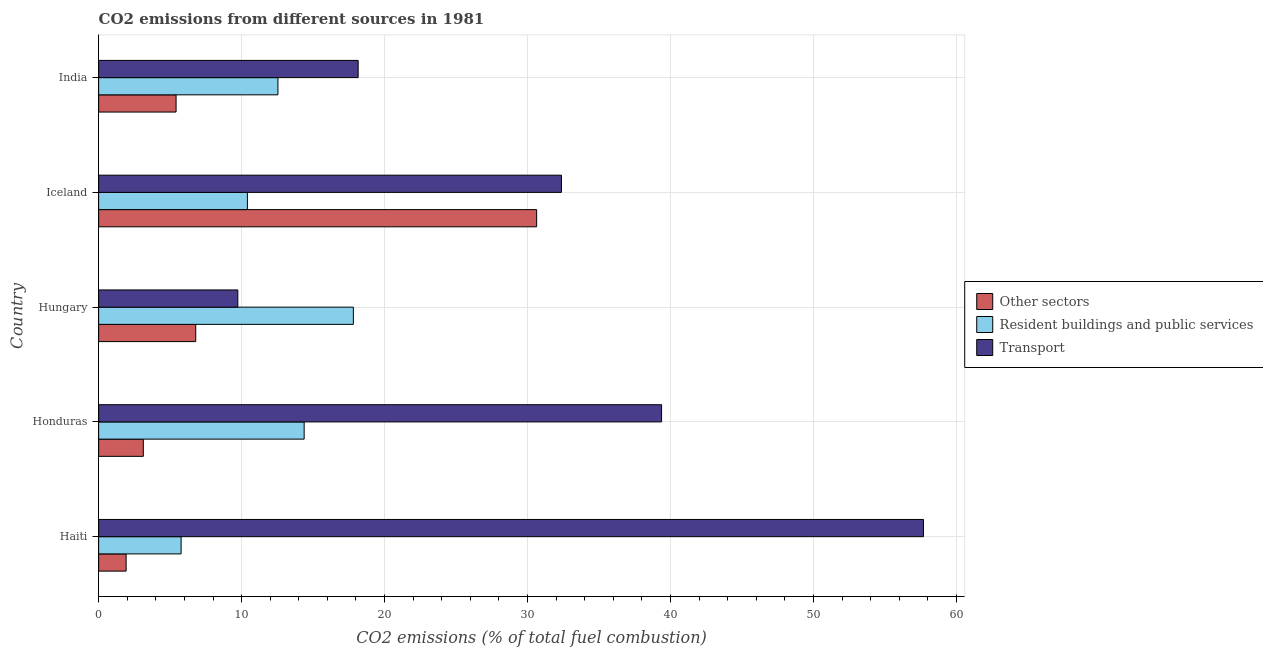How many different coloured bars are there?
Your answer should be compact. 3. Are the number of bars per tick equal to the number of legend labels?
Give a very brief answer. Yes. Are the number of bars on each tick of the Y-axis equal?
Your answer should be very brief. Yes. How many bars are there on the 2nd tick from the top?
Provide a succinct answer. 3. How many bars are there on the 4th tick from the bottom?
Give a very brief answer. 3. What is the label of the 3rd group of bars from the top?
Your answer should be very brief. Hungary. What is the percentage of co2 emissions from other sectors in Haiti?
Your answer should be very brief. 1.92. Across all countries, what is the maximum percentage of co2 emissions from resident buildings and public services?
Offer a very short reply. 17.82. Across all countries, what is the minimum percentage of co2 emissions from other sectors?
Give a very brief answer. 1.92. In which country was the percentage of co2 emissions from transport maximum?
Keep it short and to the point. Haiti. In which country was the percentage of co2 emissions from transport minimum?
Provide a succinct answer. Hungary. What is the total percentage of co2 emissions from other sectors in the graph?
Offer a very short reply. 47.89. What is the difference between the percentage of co2 emissions from other sectors in Honduras and that in Hungary?
Ensure brevity in your answer.  -3.67. What is the difference between the percentage of co2 emissions from transport in Hungary and the percentage of co2 emissions from other sectors in India?
Ensure brevity in your answer.  4.32. What is the average percentage of co2 emissions from other sectors per country?
Offer a terse response. 9.58. What is the difference between the percentage of co2 emissions from transport and percentage of co2 emissions from resident buildings and public services in Haiti?
Your response must be concise. 51.92. What is the ratio of the percentage of co2 emissions from other sectors in Haiti to that in Honduras?
Offer a very short reply. 0.61. Is the percentage of co2 emissions from other sectors in Haiti less than that in India?
Your answer should be compact. Yes. Is the difference between the percentage of co2 emissions from resident buildings and public services in Haiti and Honduras greater than the difference between the percentage of co2 emissions from other sectors in Haiti and Honduras?
Provide a succinct answer. No. What is the difference between the highest and the second highest percentage of co2 emissions from transport?
Your response must be concise. 18.32. What is the difference between the highest and the lowest percentage of co2 emissions from other sectors?
Give a very brief answer. 28.71. Is the sum of the percentage of co2 emissions from transport in Honduras and India greater than the maximum percentage of co2 emissions from resident buildings and public services across all countries?
Offer a very short reply. Yes. What does the 1st bar from the top in Honduras represents?
Give a very brief answer. Transport. What does the 2nd bar from the bottom in Iceland represents?
Provide a succinct answer. Resident buildings and public services. Is it the case that in every country, the sum of the percentage of co2 emissions from other sectors and percentage of co2 emissions from resident buildings and public services is greater than the percentage of co2 emissions from transport?
Provide a succinct answer. No. How many bars are there?
Keep it short and to the point. 15. Are all the bars in the graph horizontal?
Make the answer very short. Yes. Are the values on the major ticks of X-axis written in scientific E-notation?
Give a very brief answer. No. Does the graph contain any zero values?
Your answer should be very brief. No. Does the graph contain grids?
Give a very brief answer. Yes. What is the title of the graph?
Keep it short and to the point. CO2 emissions from different sources in 1981. Does "Poland" appear as one of the legend labels in the graph?
Your response must be concise. No. What is the label or title of the X-axis?
Ensure brevity in your answer.  CO2 emissions (% of total fuel combustion). What is the CO2 emissions (% of total fuel combustion) in Other sectors in Haiti?
Your response must be concise. 1.92. What is the CO2 emissions (% of total fuel combustion) of Resident buildings and public services in Haiti?
Make the answer very short. 5.77. What is the CO2 emissions (% of total fuel combustion) in Transport in Haiti?
Ensure brevity in your answer.  57.69. What is the CO2 emissions (% of total fuel combustion) of Other sectors in Honduras?
Your answer should be very brief. 3.12. What is the CO2 emissions (% of total fuel combustion) of Resident buildings and public services in Honduras?
Offer a terse response. 14.38. What is the CO2 emissions (% of total fuel combustion) of Transport in Honduras?
Make the answer very short. 39.38. What is the CO2 emissions (% of total fuel combustion) in Other sectors in Hungary?
Make the answer very short. 6.79. What is the CO2 emissions (% of total fuel combustion) of Resident buildings and public services in Hungary?
Your response must be concise. 17.82. What is the CO2 emissions (% of total fuel combustion) in Transport in Hungary?
Your response must be concise. 9.73. What is the CO2 emissions (% of total fuel combustion) of Other sectors in Iceland?
Give a very brief answer. 30.64. What is the CO2 emissions (% of total fuel combustion) in Resident buildings and public services in Iceland?
Give a very brief answer. 10.4. What is the CO2 emissions (% of total fuel combustion) in Transport in Iceland?
Make the answer very short. 32.37. What is the CO2 emissions (% of total fuel combustion) of Other sectors in India?
Keep it short and to the point. 5.42. What is the CO2 emissions (% of total fuel combustion) in Resident buildings and public services in India?
Your answer should be very brief. 12.54. What is the CO2 emissions (% of total fuel combustion) in Transport in India?
Provide a succinct answer. 18.15. Across all countries, what is the maximum CO2 emissions (% of total fuel combustion) in Other sectors?
Your answer should be compact. 30.64. Across all countries, what is the maximum CO2 emissions (% of total fuel combustion) of Resident buildings and public services?
Your answer should be very brief. 17.82. Across all countries, what is the maximum CO2 emissions (% of total fuel combustion) in Transport?
Make the answer very short. 57.69. Across all countries, what is the minimum CO2 emissions (% of total fuel combustion) in Other sectors?
Make the answer very short. 1.92. Across all countries, what is the minimum CO2 emissions (% of total fuel combustion) of Resident buildings and public services?
Offer a very short reply. 5.77. Across all countries, what is the minimum CO2 emissions (% of total fuel combustion) of Transport?
Offer a terse response. 9.73. What is the total CO2 emissions (% of total fuel combustion) of Other sectors in the graph?
Provide a succinct answer. 47.89. What is the total CO2 emissions (% of total fuel combustion) of Resident buildings and public services in the graph?
Your answer should be very brief. 60.91. What is the total CO2 emissions (% of total fuel combustion) in Transport in the graph?
Your answer should be compact. 157.32. What is the difference between the CO2 emissions (% of total fuel combustion) in Other sectors in Haiti and that in Honduras?
Offer a terse response. -1.2. What is the difference between the CO2 emissions (% of total fuel combustion) of Resident buildings and public services in Haiti and that in Honduras?
Your response must be concise. -8.61. What is the difference between the CO2 emissions (% of total fuel combustion) of Transport in Haiti and that in Honduras?
Give a very brief answer. 18.32. What is the difference between the CO2 emissions (% of total fuel combustion) in Other sectors in Haiti and that in Hungary?
Keep it short and to the point. -4.87. What is the difference between the CO2 emissions (% of total fuel combustion) in Resident buildings and public services in Haiti and that in Hungary?
Provide a succinct answer. -12.05. What is the difference between the CO2 emissions (% of total fuel combustion) in Transport in Haiti and that in Hungary?
Offer a very short reply. 47.96. What is the difference between the CO2 emissions (% of total fuel combustion) in Other sectors in Haiti and that in Iceland?
Your answer should be compact. -28.71. What is the difference between the CO2 emissions (% of total fuel combustion) of Resident buildings and public services in Haiti and that in Iceland?
Provide a succinct answer. -4.64. What is the difference between the CO2 emissions (% of total fuel combustion) of Transport in Haiti and that in Iceland?
Ensure brevity in your answer.  25.32. What is the difference between the CO2 emissions (% of total fuel combustion) of Other sectors in Haiti and that in India?
Offer a very short reply. -3.49. What is the difference between the CO2 emissions (% of total fuel combustion) of Resident buildings and public services in Haiti and that in India?
Your answer should be compact. -6.77. What is the difference between the CO2 emissions (% of total fuel combustion) of Transport in Haiti and that in India?
Your answer should be compact. 39.54. What is the difference between the CO2 emissions (% of total fuel combustion) of Other sectors in Honduras and that in Hungary?
Provide a short and direct response. -3.67. What is the difference between the CO2 emissions (% of total fuel combustion) of Resident buildings and public services in Honduras and that in Hungary?
Make the answer very short. -3.44. What is the difference between the CO2 emissions (% of total fuel combustion) in Transport in Honduras and that in Hungary?
Provide a short and direct response. 29.64. What is the difference between the CO2 emissions (% of total fuel combustion) in Other sectors in Honduras and that in Iceland?
Offer a terse response. -27.51. What is the difference between the CO2 emissions (% of total fuel combustion) in Resident buildings and public services in Honduras and that in Iceland?
Offer a very short reply. 3.97. What is the difference between the CO2 emissions (% of total fuel combustion) of Transport in Honduras and that in Iceland?
Provide a short and direct response. 7.01. What is the difference between the CO2 emissions (% of total fuel combustion) in Other sectors in Honduras and that in India?
Keep it short and to the point. -2.29. What is the difference between the CO2 emissions (% of total fuel combustion) of Resident buildings and public services in Honduras and that in India?
Provide a short and direct response. 1.83. What is the difference between the CO2 emissions (% of total fuel combustion) of Transport in Honduras and that in India?
Keep it short and to the point. 21.22. What is the difference between the CO2 emissions (% of total fuel combustion) of Other sectors in Hungary and that in Iceland?
Your answer should be compact. -23.84. What is the difference between the CO2 emissions (% of total fuel combustion) of Resident buildings and public services in Hungary and that in Iceland?
Your answer should be compact. 7.41. What is the difference between the CO2 emissions (% of total fuel combustion) in Transport in Hungary and that in Iceland?
Offer a very short reply. -22.64. What is the difference between the CO2 emissions (% of total fuel combustion) in Other sectors in Hungary and that in India?
Offer a terse response. 1.37. What is the difference between the CO2 emissions (% of total fuel combustion) of Resident buildings and public services in Hungary and that in India?
Ensure brevity in your answer.  5.28. What is the difference between the CO2 emissions (% of total fuel combustion) in Transport in Hungary and that in India?
Make the answer very short. -8.42. What is the difference between the CO2 emissions (% of total fuel combustion) of Other sectors in Iceland and that in India?
Your answer should be compact. 25.22. What is the difference between the CO2 emissions (% of total fuel combustion) of Resident buildings and public services in Iceland and that in India?
Ensure brevity in your answer.  -2.14. What is the difference between the CO2 emissions (% of total fuel combustion) in Transport in Iceland and that in India?
Your answer should be compact. 14.22. What is the difference between the CO2 emissions (% of total fuel combustion) in Other sectors in Haiti and the CO2 emissions (% of total fuel combustion) in Resident buildings and public services in Honduras?
Your answer should be very brief. -12.45. What is the difference between the CO2 emissions (% of total fuel combustion) of Other sectors in Haiti and the CO2 emissions (% of total fuel combustion) of Transport in Honduras?
Your answer should be very brief. -37.45. What is the difference between the CO2 emissions (% of total fuel combustion) of Resident buildings and public services in Haiti and the CO2 emissions (% of total fuel combustion) of Transport in Honduras?
Provide a succinct answer. -33.61. What is the difference between the CO2 emissions (% of total fuel combustion) of Other sectors in Haiti and the CO2 emissions (% of total fuel combustion) of Resident buildings and public services in Hungary?
Keep it short and to the point. -15.89. What is the difference between the CO2 emissions (% of total fuel combustion) in Other sectors in Haiti and the CO2 emissions (% of total fuel combustion) in Transport in Hungary?
Your response must be concise. -7.81. What is the difference between the CO2 emissions (% of total fuel combustion) of Resident buildings and public services in Haiti and the CO2 emissions (% of total fuel combustion) of Transport in Hungary?
Your answer should be compact. -3.97. What is the difference between the CO2 emissions (% of total fuel combustion) in Other sectors in Haiti and the CO2 emissions (% of total fuel combustion) in Resident buildings and public services in Iceland?
Offer a terse response. -8.48. What is the difference between the CO2 emissions (% of total fuel combustion) in Other sectors in Haiti and the CO2 emissions (% of total fuel combustion) in Transport in Iceland?
Your answer should be very brief. -30.45. What is the difference between the CO2 emissions (% of total fuel combustion) of Resident buildings and public services in Haiti and the CO2 emissions (% of total fuel combustion) of Transport in Iceland?
Give a very brief answer. -26.6. What is the difference between the CO2 emissions (% of total fuel combustion) in Other sectors in Haiti and the CO2 emissions (% of total fuel combustion) in Resident buildings and public services in India?
Provide a short and direct response. -10.62. What is the difference between the CO2 emissions (% of total fuel combustion) in Other sectors in Haiti and the CO2 emissions (% of total fuel combustion) in Transport in India?
Provide a short and direct response. -16.23. What is the difference between the CO2 emissions (% of total fuel combustion) in Resident buildings and public services in Haiti and the CO2 emissions (% of total fuel combustion) in Transport in India?
Ensure brevity in your answer.  -12.38. What is the difference between the CO2 emissions (% of total fuel combustion) of Other sectors in Honduras and the CO2 emissions (% of total fuel combustion) of Resident buildings and public services in Hungary?
Offer a terse response. -14.69. What is the difference between the CO2 emissions (% of total fuel combustion) in Other sectors in Honduras and the CO2 emissions (% of total fuel combustion) in Transport in Hungary?
Your response must be concise. -6.61. What is the difference between the CO2 emissions (% of total fuel combustion) in Resident buildings and public services in Honduras and the CO2 emissions (% of total fuel combustion) in Transport in Hungary?
Ensure brevity in your answer.  4.64. What is the difference between the CO2 emissions (% of total fuel combustion) of Other sectors in Honduras and the CO2 emissions (% of total fuel combustion) of Resident buildings and public services in Iceland?
Provide a succinct answer. -7.28. What is the difference between the CO2 emissions (% of total fuel combustion) in Other sectors in Honduras and the CO2 emissions (% of total fuel combustion) in Transport in Iceland?
Offer a very short reply. -29.24. What is the difference between the CO2 emissions (% of total fuel combustion) in Resident buildings and public services in Honduras and the CO2 emissions (% of total fuel combustion) in Transport in Iceland?
Your answer should be compact. -17.99. What is the difference between the CO2 emissions (% of total fuel combustion) in Other sectors in Honduras and the CO2 emissions (% of total fuel combustion) in Resident buildings and public services in India?
Provide a succinct answer. -9.42. What is the difference between the CO2 emissions (% of total fuel combustion) of Other sectors in Honduras and the CO2 emissions (% of total fuel combustion) of Transport in India?
Your response must be concise. -15.03. What is the difference between the CO2 emissions (% of total fuel combustion) of Resident buildings and public services in Honduras and the CO2 emissions (% of total fuel combustion) of Transport in India?
Keep it short and to the point. -3.78. What is the difference between the CO2 emissions (% of total fuel combustion) of Other sectors in Hungary and the CO2 emissions (% of total fuel combustion) of Resident buildings and public services in Iceland?
Keep it short and to the point. -3.61. What is the difference between the CO2 emissions (% of total fuel combustion) in Other sectors in Hungary and the CO2 emissions (% of total fuel combustion) in Transport in Iceland?
Provide a short and direct response. -25.58. What is the difference between the CO2 emissions (% of total fuel combustion) of Resident buildings and public services in Hungary and the CO2 emissions (% of total fuel combustion) of Transport in Iceland?
Offer a terse response. -14.55. What is the difference between the CO2 emissions (% of total fuel combustion) of Other sectors in Hungary and the CO2 emissions (% of total fuel combustion) of Resident buildings and public services in India?
Keep it short and to the point. -5.75. What is the difference between the CO2 emissions (% of total fuel combustion) of Other sectors in Hungary and the CO2 emissions (% of total fuel combustion) of Transport in India?
Offer a very short reply. -11.36. What is the difference between the CO2 emissions (% of total fuel combustion) in Resident buildings and public services in Hungary and the CO2 emissions (% of total fuel combustion) in Transport in India?
Give a very brief answer. -0.34. What is the difference between the CO2 emissions (% of total fuel combustion) in Other sectors in Iceland and the CO2 emissions (% of total fuel combustion) in Resident buildings and public services in India?
Provide a short and direct response. 18.09. What is the difference between the CO2 emissions (% of total fuel combustion) in Other sectors in Iceland and the CO2 emissions (% of total fuel combustion) in Transport in India?
Your answer should be compact. 12.48. What is the difference between the CO2 emissions (% of total fuel combustion) of Resident buildings and public services in Iceland and the CO2 emissions (% of total fuel combustion) of Transport in India?
Offer a terse response. -7.75. What is the average CO2 emissions (% of total fuel combustion) of Other sectors per country?
Ensure brevity in your answer.  9.58. What is the average CO2 emissions (% of total fuel combustion) of Resident buildings and public services per country?
Your response must be concise. 12.18. What is the average CO2 emissions (% of total fuel combustion) of Transport per country?
Your answer should be compact. 31.46. What is the difference between the CO2 emissions (% of total fuel combustion) in Other sectors and CO2 emissions (% of total fuel combustion) in Resident buildings and public services in Haiti?
Your answer should be compact. -3.85. What is the difference between the CO2 emissions (% of total fuel combustion) of Other sectors and CO2 emissions (% of total fuel combustion) of Transport in Haiti?
Provide a short and direct response. -55.77. What is the difference between the CO2 emissions (% of total fuel combustion) in Resident buildings and public services and CO2 emissions (% of total fuel combustion) in Transport in Haiti?
Your response must be concise. -51.92. What is the difference between the CO2 emissions (% of total fuel combustion) of Other sectors and CO2 emissions (% of total fuel combustion) of Resident buildings and public services in Honduras?
Provide a succinct answer. -11.25. What is the difference between the CO2 emissions (% of total fuel combustion) in Other sectors and CO2 emissions (% of total fuel combustion) in Transport in Honduras?
Ensure brevity in your answer.  -36.25. What is the difference between the CO2 emissions (% of total fuel combustion) in Resident buildings and public services and CO2 emissions (% of total fuel combustion) in Transport in Honduras?
Your response must be concise. -25. What is the difference between the CO2 emissions (% of total fuel combustion) in Other sectors and CO2 emissions (% of total fuel combustion) in Resident buildings and public services in Hungary?
Provide a succinct answer. -11.03. What is the difference between the CO2 emissions (% of total fuel combustion) in Other sectors and CO2 emissions (% of total fuel combustion) in Transport in Hungary?
Your response must be concise. -2.94. What is the difference between the CO2 emissions (% of total fuel combustion) of Resident buildings and public services and CO2 emissions (% of total fuel combustion) of Transport in Hungary?
Offer a very short reply. 8.08. What is the difference between the CO2 emissions (% of total fuel combustion) of Other sectors and CO2 emissions (% of total fuel combustion) of Resident buildings and public services in Iceland?
Your answer should be very brief. 20.23. What is the difference between the CO2 emissions (% of total fuel combustion) in Other sectors and CO2 emissions (% of total fuel combustion) in Transport in Iceland?
Offer a terse response. -1.73. What is the difference between the CO2 emissions (% of total fuel combustion) in Resident buildings and public services and CO2 emissions (% of total fuel combustion) in Transport in Iceland?
Provide a short and direct response. -21.97. What is the difference between the CO2 emissions (% of total fuel combustion) in Other sectors and CO2 emissions (% of total fuel combustion) in Resident buildings and public services in India?
Your answer should be very brief. -7.12. What is the difference between the CO2 emissions (% of total fuel combustion) in Other sectors and CO2 emissions (% of total fuel combustion) in Transport in India?
Offer a very short reply. -12.74. What is the difference between the CO2 emissions (% of total fuel combustion) of Resident buildings and public services and CO2 emissions (% of total fuel combustion) of Transport in India?
Your response must be concise. -5.61. What is the ratio of the CO2 emissions (% of total fuel combustion) in Other sectors in Haiti to that in Honduras?
Your answer should be very brief. 0.62. What is the ratio of the CO2 emissions (% of total fuel combustion) of Resident buildings and public services in Haiti to that in Honduras?
Make the answer very short. 0.4. What is the ratio of the CO2 emissions (% of total fuel combustion) of Transport in Haiti to that in Honduras?
Your answer should be compact. 1.47. What is the ratio of the CO2 emissions (% of total fuel combustion) of Other sectors in Haiti to that in Hungary?
Make the answer very short. 0.28. What is the ratio of the CO2 emissions (% of total fuel combustion) in Resident buildings and public services in Haiti to that in Hungary?
Your answer should be very brief. 0.32. What is the ratio of the CO2 emissions (% of total fuel combustion) of Transport in Haiti to that in Hungary?
Your response must be concise. 5.93. What is the ratio of the CO2 emissions (% of total fuel combustion) of Other sectors in Haiti to that in Iceland?
Make the answer very short. 0.06. What is the ratio of the CO2 emissions (% of total fuel combustion) in Resident buildings and public services in Haiti to that in Iceland?
Ensure brevity in your answer.  0.55. What is the ratio of the CO2 emissions (% of total fuel combustion) in Transport in Haiti to that in Iceland?
Your answer should be compact. 1.78. What is the ratio of the CO2 emissions (% of total fuel combustion) in Other sectors in Haiti to that in India?
Ensure brevity in your answer.  0.35. What is the ratio of the CO2 emissions (% of total fuel combustion) of Resident buildings and public services in Haiti to that in India?
Offer a very short reply. 0.46. What is the ratio of the CO2 emissions (% of total fuel combustion) in Transport in Haiti to that in India?
Keep it short and to the point. 3.18. What is the ratio of the CO2 emissions (% of total fuel combustion) of Other sectors in Honduras to that in Hungary?
Offer a very short reply. 0.46. What is the ratio of the CO2 emissions (% of total fuel combustion) in Resident buildings and public services in Honduras to that in Hungary?
Offer a very short reply. 0.81. What is the ratio of the CO2 emissions (% of total fuel combustion) of Transport in Honduras to that in Hungary?
Offer a terse response. 4.04. What is the ratio of the CO2 emissions (% of total fuel combustion) of Other sectors in Honduras to that in Iceland?
Your answer should be compact. 0.1. What is the ratio of the CO2 emissions (% of total fuel combustion) of Resident buildings and public services in Honduras to that in Iceland?
Offer a terse response. 1.38. What is the ratio of the CO2 emissions (% of total fuel combustion) of Transport in Honduras to that in Iceland?
Your answer should be very brief. 1.22. What is the ratio of the CO2 emissions (% of total fuel combustion) of Other sectors in Honduras to that in India?
Offer a very short reply. 0.58. What is the ratio of the CO2 emissions (% of total fuel combustion) in Resident buildings and public services in Honduras to that in India?
Offer a terse response. 1.15. What is the ratio of the CO2 emissions (% of total fuel combustion) in Transport in Honduras to that in India?
Provide a short and direct response. 2.17. What is the ratio of the CO2 emissions (% of total fuel combustion) in Other sectors in Hungary to that in Iceland?
Your response must be concise. 0.22. What is the ratio of the CO2 emissions (% of total fuel combustion) in Resident buildings and public services in Hungary to that in Iceland?
Your answer should be compact. 1.71. What is the ratio of the CO2 emissions (% of total fuel combustion) of Transport in Hungary to that in Iceland?
Offer a terse response. 0.3. What is the ratio of the CO2 emissions (% of total fuel combustion) in Other sectors in Hungary to that in India?
Offer a very short reply. 1.25. What is the ratio of the CO2 emissions (% of total fuel combustion) in Resident buildings and public services in Hungary to that in India?
Ensure brevity in your answer.  1.42. What is the ratio of the CO2 emissions (% of total fuel combustion) in Transport in Hungary to that in India?
Your answer should be compact. 0.54. What is the ratio of the CO2 emissions (% of total fuel combustion) of Other sectors in Iceland to that in India?
Provide a short and direct response. 5.66. What is the ratio of the CO2 emissions (% of total fuel combustion) in Resident buildings and public services in Iceland to that in India?
Your answer should be compact. 0.83. What is the ratio of the CO2 emissions (% of total fuel combustion) in Transport in Iceland to that in India?
Your answer should be very brief. 1.78. What is the difference between the highest and the second highest CO2 emissions (% of total fuel combustion) in Other sectors?
Provide a short and direct response. 23.84. What is the difference between the highest and the second highest CO2 emissions (% of total fuel combustion) of Resident buildings and public services?
Give a very brief answer. 3.44. What is the difference between the highest and the second highest CO2 emissions (% of total fuel combustion) in Transport?
Your answer should be compact. 18.32. What is the difference between the highest and the lowest CO2 emissions (% of total fuel combustion) in Other sectors?
Give a very brief answer. 28.71. What is the difference between the highest and the lowest CO2 emissions (% of total fuel combustion) of Resident buildings and public services?
Offer a terse response. 12.05. What is the difference between the highest and the lowest CO2 emissions (% of total fuel combustion) in Transport?
Your response must be concise. 47.96. 